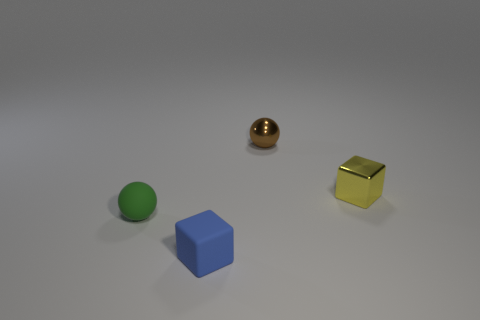Add 1 cyan matte spheres. How many objects exist? 5 Subtract all green things. Subtract all small red cylinders. How many objects are left? 3 Add 4 blue things. How many blue things are left? 5 Add 2 small yellow metal cubes. How many small yellow metal cubes exist? 3 Subtract 0 gray balls. How many objects are left? 4 